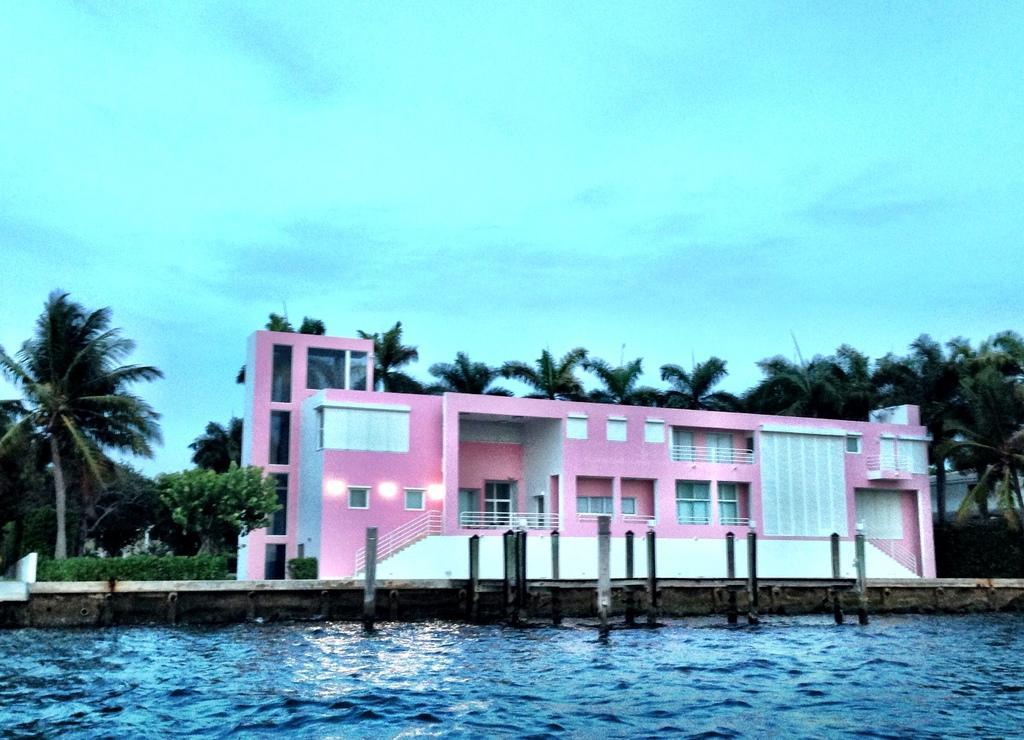Could you give a brief overview of what you see in this image? In the foreground of the picture there is water. In the center of the picture there are plants, trees, palm trees, buildings and a dock. Sky is cloudy. 